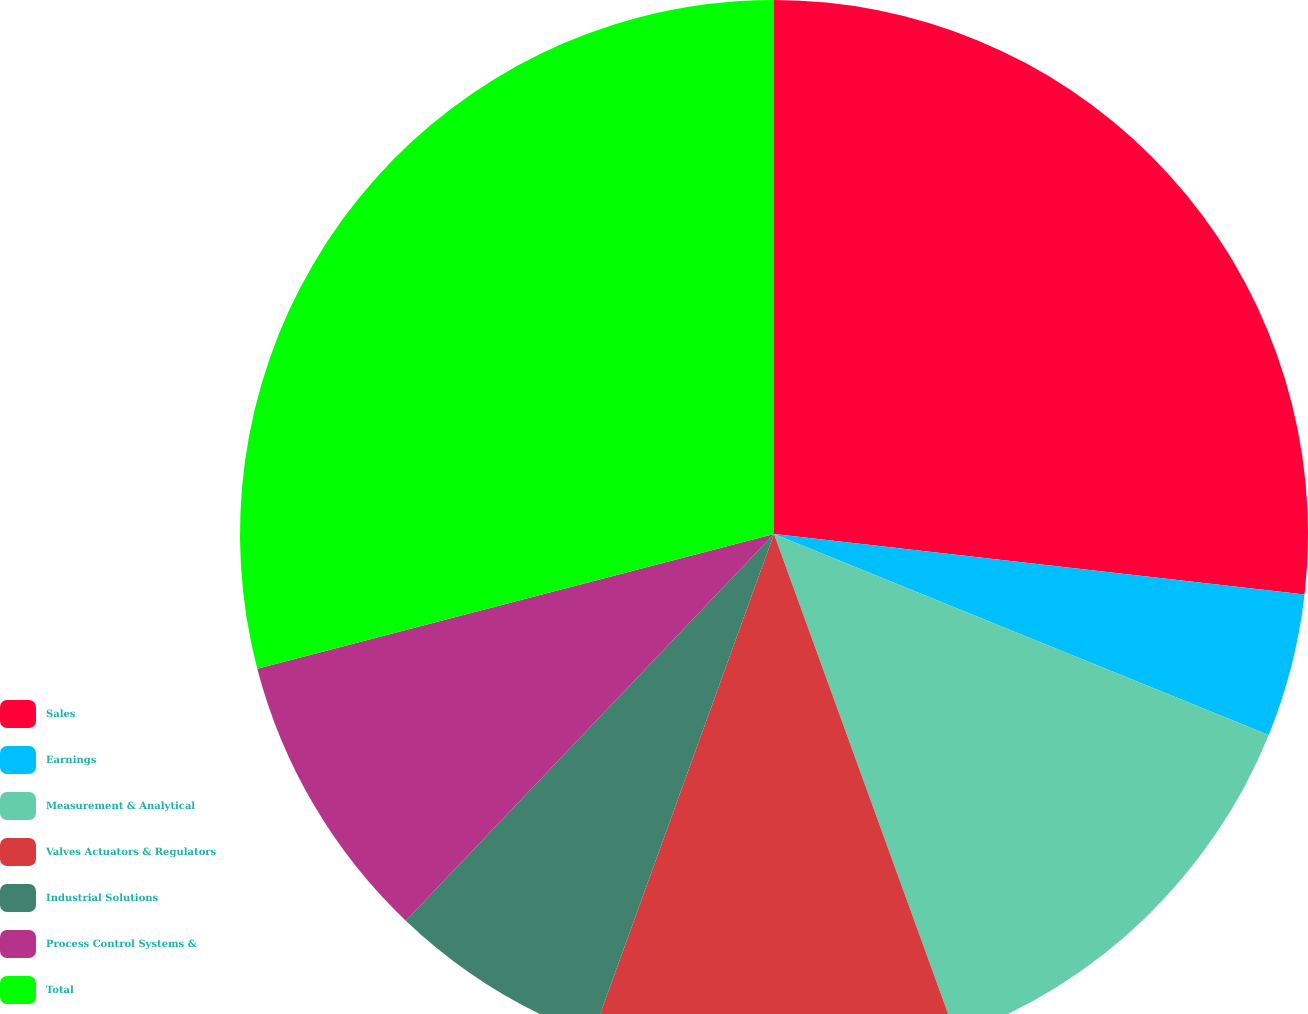Convert chart. <chart><loc_0><loc_0><loc_500><loc_500><pie_chart><fcel>Sales<fcel>Earnings<fcel>Measurement & Analytical<fcel>Valves Actuators & Regulators<fcel>Industrial Solutions<fcel>Process Control Systems &<fcel>Total<nl><fcel>26.81%<fcel>4.33%<fcel>13.32%<fcel>11.07%<fcel>6.58%<fcel>8.83%<fcel>29.06%<nl></chart> 